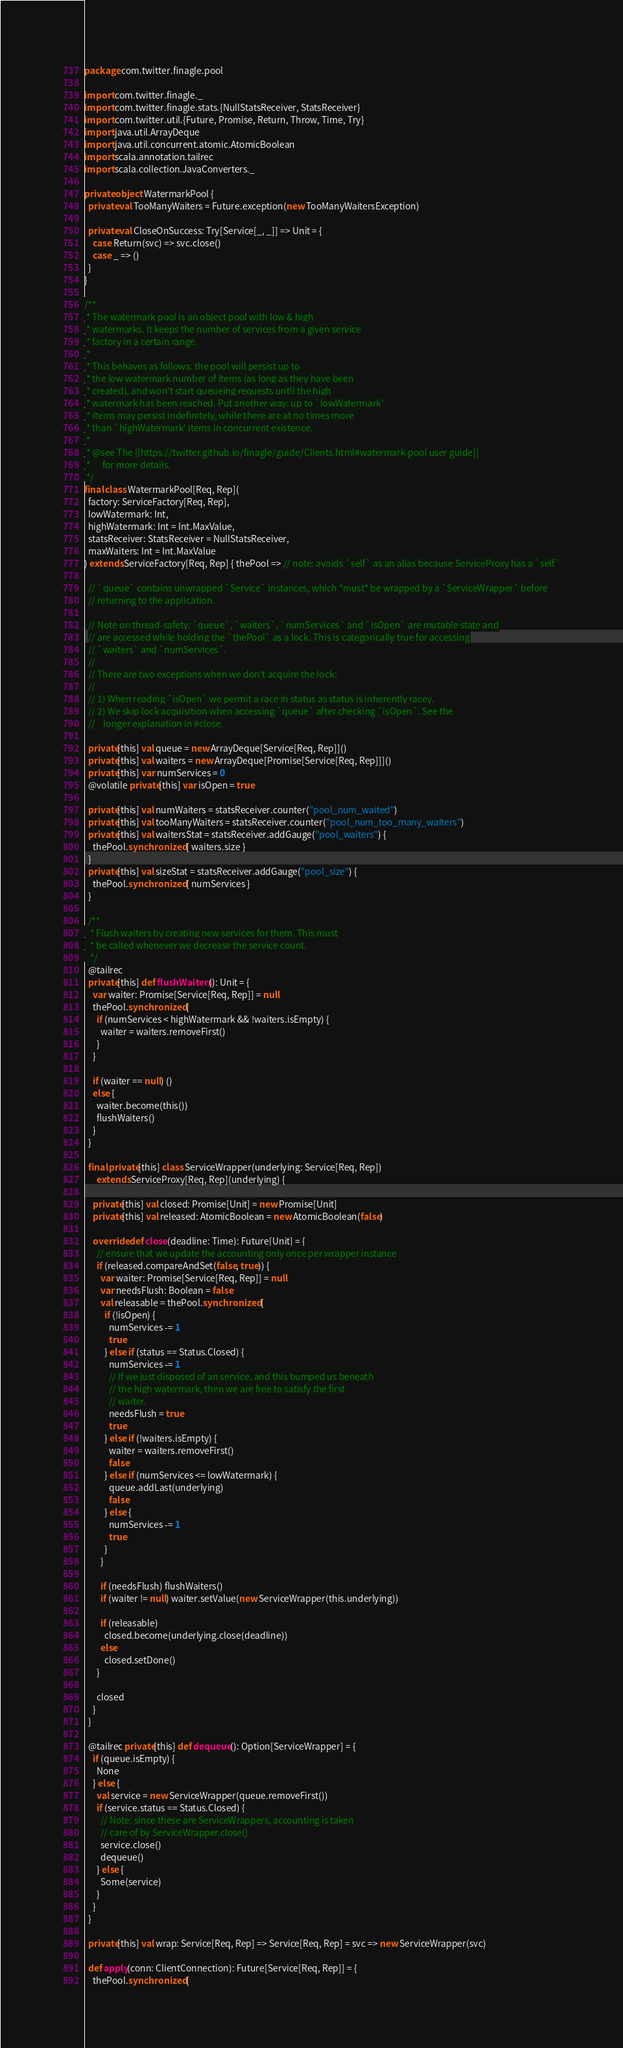<code> <loc_0><loc_0><loc_500><loc_500><_Scala_>package com.twitter.finagle.pool

import com.twitter.finagle._
import com.twitter.finagle.stats.{NullStatsReceiver, StatsReceiver}
import com.twitter.util.{Future, Promise, Return, Throw, Time, Try}
import java.util.ArrayDeque
import java.util.concurrent.atomic.AtomicBoolean
import scala.annotation.tailrec
import scala.collection.JavaConverters._

private object WatermarkPool {
  private val TooManyWaiters = Future.exception(new TooManyWaitersException)

  private val CloseOnSuccess: Try[Service[_, _]] => Unit = {
    case Return(svc) => svc.close()
    case _ => ()
  }
}

/**
 * The watermark pool is an object pool with low & high
 * watermarks. It keeps the number of services from a given service
 * factory in a certain range.
 *
 * This behaves as follows: the pool will persist up to
 * the low watermark number of items (as long as they have been
 * created), and won't start queueing requests until the high
 * watermark has been reached. Put another way: up to `lowWatermark'
 * items may persist indefinitely, while there are at no times more
 * than `highWatermark' items in concurrent existence.
 *
 * @see The [[https://twitter.github.io/finagle/guide/Clients.html#watermark-pool user guide]]
 *      for more details.
 */
final class WatermarkPool[Req, Rep](
  factory: ServiceFactory[Req, Rep],
  lowWatermark: Int,
  highWatermark: Int = Int.MaxValue,
  statsReceiver: StatsReceiver = NullStatsReceiver,
  maxWaiters: Int = Int.MaxValue
) extends ServiceFactory[Req, Rep] { thePool => // note: avoids `self` as an alias because ServiceProxy has a `self`

  // `queue` contains unwrapped `Service` instances, which *must* be wrapped by a `ServiceWrapper` before
  // returning to the application.

  // Note on thread-safety: `queue`, `waiters`, `numServices` and `isOpen` are mutable state and
  // are accessed while holding the `thePool` as a lock. This is categorically true for accessing
  // `waiters` and `numServices`.
  //
  // There are two exceptions when we don't acquire the lock:
  //
  // 1) When reading `isOpen` we permit a race in status as status is inherently racey.
  // 2) We skip lock acquisition when accessing `queue` after checking `isOpen`. See the
  //    longer explanation in #close.

  private[this] val queue = new ArrayDeque[Service[Req, Rep]]()
  private[this] val waiters = new ArrayDeque[Promise[Service[Req, Rep]]]()
  private[this] var numServices = 0
  @volatile private[this] var isOpen = true

  private[this] val numWaiters = statsReceiver.counter("pool_num_waited")
  private[this] val tooManyWaiters = statsReceiver.counter("pool_num_too_many_waiters")
  private[this] val waitersStat = statsReceiver.addGauge("pool_waiters") {
    thePool.synchronized { waiters.size }
  }
  private[this] val sizeStat = statsReceiver.addGauge("pool_size") {
    thePool.synchronized { numServices }
  }

  /**
   * Flush waiters by creating new services for them. This must
   * be called whenever we decrease the service count.
   */
  @tailrec
  private[this] def flushWaiters(): Unit = {
    var waiter: Promise[Service[Req, Rep]] = null
    thePool.synchronized {
      if (numServices < highWatermark && !waiters.isEmpty) {
        waiter = waiters.removeFirst()
      }
    }

    if (waiter == null) ()
    else {
      waiter.become(this())
      flushWaiters()
    }
  }

  final private[this] class ServiceWrapper(underlying: Service[Req, Rep])
      extends ServiceProxy[Req, Rep](underlying) {

    private[this] val closed: Promise[Unit] = new Promise[Unit]
    private[this] val released: AtomicBoolean = new AtomicBoolean(false)

    override def close(deadline: Time): Future[Unit] = {
      // ensure that we update the accounting only once per wrapper instance
      if (released.compareAndSet(false, true)) {
        var waiter: Promise[Service[Req, Rep]] = null
        var needsFlush: Boolean = false
        val releasable = thePool.synchronized {
          if (!isOpen) {
            numServices -= 1
            true
          } else if (status == Status.Closed) {
            numServices -= 1
            // If we just disposed of an service, and this bumped us beneath
            // the high watermark, then we are free to satisfy the first
            // waiter.
            needsFlush = true
            true
          } else if (!waiters.isEmpty) {
            waiter = waiters.removeFirst()
            false
          } else if (numServices <= lowWatermark) {
            queue.addLast(underlying)
            false
          } else {
            numServices -= 1
            true
          }
        }

        if (needsFlush) flushWaiters()
        if (waiter != null) waiter.setValue(new ServiceWrapper(this.underlying))

        if (releasable)
          closed.become(underlying.close(deadline))
        else
          closed.setDone()
      }

      closed
    }
  }

  @tailrec private[this] def dequeue(): Option[ServiceWrapper] = {
    if (queue.isEmpty) {
      None
    } else {
      val service = new ServiceWrapper(queue.removeFirst())
      if (service.status == Status.Closed) {
        // Note: since these are ServiceWrappers, accounting is taken
        // care of by ServiceWrapper.close()
        service.close()
        dequeue()
      } else {
        Some(service)
      }
    }
  }

  private[this] val wrap: Service[Req, Rep] => Service[Req, Rep] = svc => new ServiceWrapper(svc)

  def apply(conn: ClientConnection): Future[Service[Req, Rep]] = {
    thePool.synchronized {</code> 